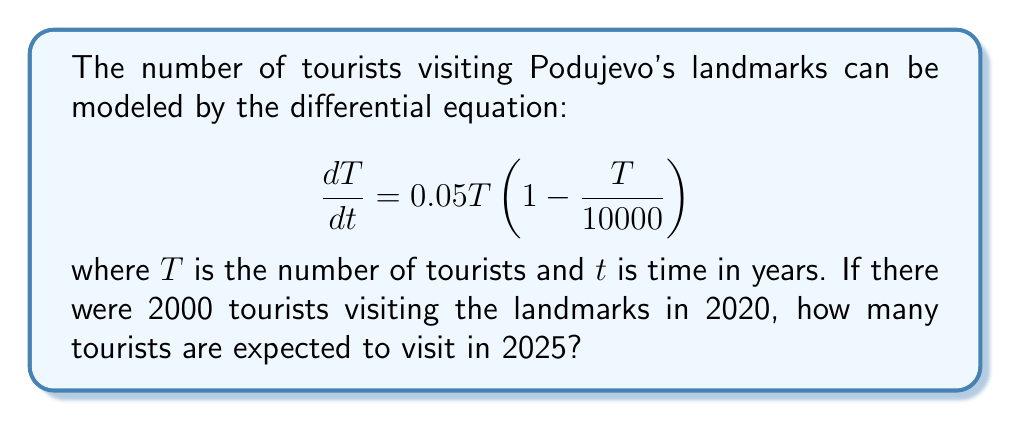Could you help me with this problem? To solve this problem, we need to use the given differential equation and initial condition to find the number of tourists after 5 years.

1. The given differential equation is a logistic growth model:
   $$\frac{dT}{dt} = 0.05T(1 - \frac{T}{10000})$$

2. The initial condition is $T(0) = 2000$ (assuming 2020 is our starting point, t = 0).

3. The solution to the logistic growth model is:
   $$T(t) = \frac{K}{1 + (\frac{K}{T_0} - 1)e^{-rt}}$$
   
   Where:
   - $K$ is the carrying capacity (10000 in this case)
   - $T_0$ is the initial population (2000)
   - $r$ is the growth rate (0.05)

4. Substituting our values:
   $$T(t) = \frac{10000}{1 + (\frac{10000}{2000} - 1)e^{-0.05t}}$$

5. Simplify:
   $$T(t) = \frac{10000}{1 + 4e^{-0.05t}}$$

6. We want to find $T(5)$, so let's substitute $t = 5$:
   $$T(5) = \frac{10000}{1 + 4e^{-0.05(5)}}$$

7. Calculate:
   $$T(5) = \frac{10000}{1 + 4e^{-0.25}} \approx 3296.95$$

8. Round to the nearest whole number, as we can't have fractional tourists.
Answer: The expected number of tourists visiting Podujevo's landmarks in 2025 is approximately 3297. 